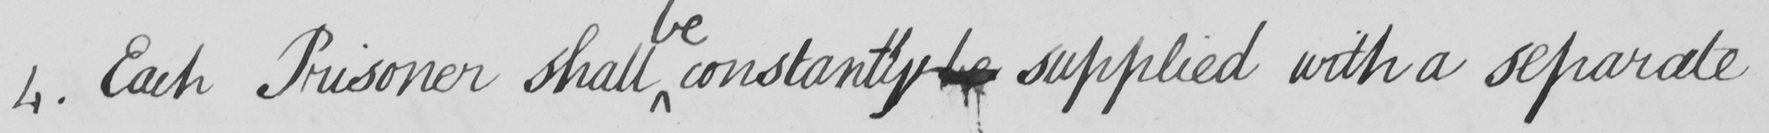Please transcribe the handwritten text in this image. 4 . Each Prisoner shall constantly be supplied with a separate 